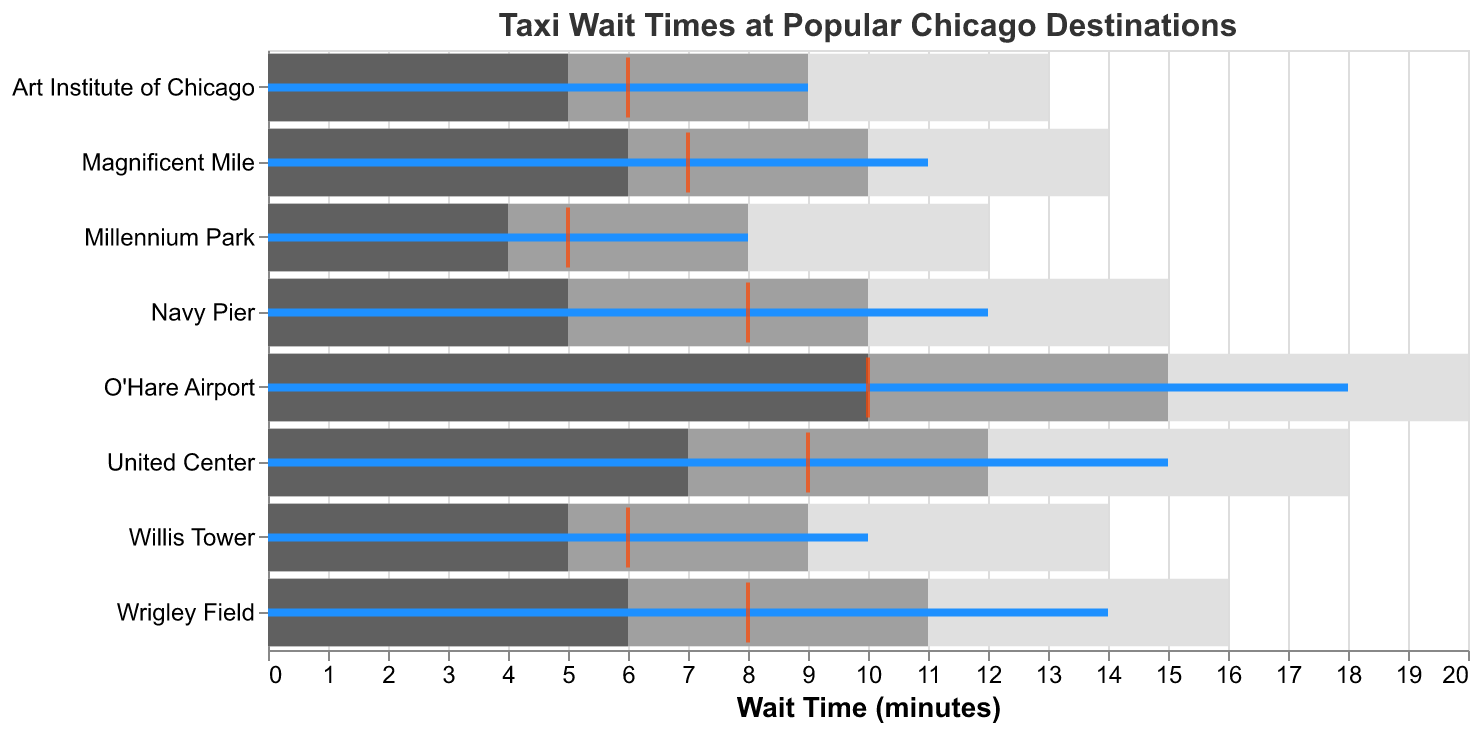What's the title of the figure? The title of the figure is located at the top and describes the context of the data.
Answer: Taxi Wait Times at Popular Chicago Destinations How many destinations are included in the figure? By counting the number of distinct locations along the Y-axis of the figure, we can determine the total number of destinations.
Answer: 8 What's the actual wait time at O'Hare Airport? The bar for O'Hare Airport has a specific length, indicated in blue, representing the actual wait time.
Answer: 18 minutes Which location has the shortest actual wait time? We can compare the lengths of the blue bars representing the actual wait times across all locations to find the shortest one.
Answer: Millennium Park How does the actual wait time at Navy Pier compare to its target wait time? The blue bar (actual wait time) and the orange tick (target wait time) for Navy Pier can be compared visually. The actual wait time is 12 minutes, and the target wait time is 8 minutes.
Answer: Actual wait time is 4 minutes longer than the target wait time What is the difference between the actual wait time and the typical wait time at United Center? Subtract the typical wait time from the actual wait time for United Center. The actual wait time is 15 minutes, and the typical wait time is 12 minutes.
Answer: 3 minutes Which location meets its satisfactory performance level but does not achieve good performance based on its actual wait time? We need to identify the locations where the actual wait time falls in the satisfactory performance range but not in the good performance range. The actual wait time at Art Institute of Chicago is 9 minutes, which is within satisfactory (8-9 minutes) but not good (above 6 minutes).
Answer: Art Institute of Chicago What's the sum of the target wait times for all destinations? Add up the target wait times from all the listed locations: 10 + 8 + 5 + 6 + 9 + 8 + 6 + 7.
Answer: 59 minutes Which location has the largest difference between poor performance and good performance thresholds? Subtract the good performance threshold from the poor performance threshold for each location and find the maximum difference. For O'Hare Airport, it's 20 - 10 = 10. For the others: Navy Pier 10, Millennium Park 8, Willis Tower 9, United Center 11, Wrigley Field 10, Art Institute of Chicago 8, Magnificent Mile 8.
Answer: United Center How do the wait times at Willis Tower compare to those at Navy Pier? Compare the actual wait, typical wait, and target wait times for Willis Tower and Navy Pier. Willis Tower: 10 (actual), 8 (typical), 6 (target). Navy Pier: 12 (actual), 10 (typical), 8 (target).
Answer: Willis Tower has shorter wait times than Navy Pier across all metrics 